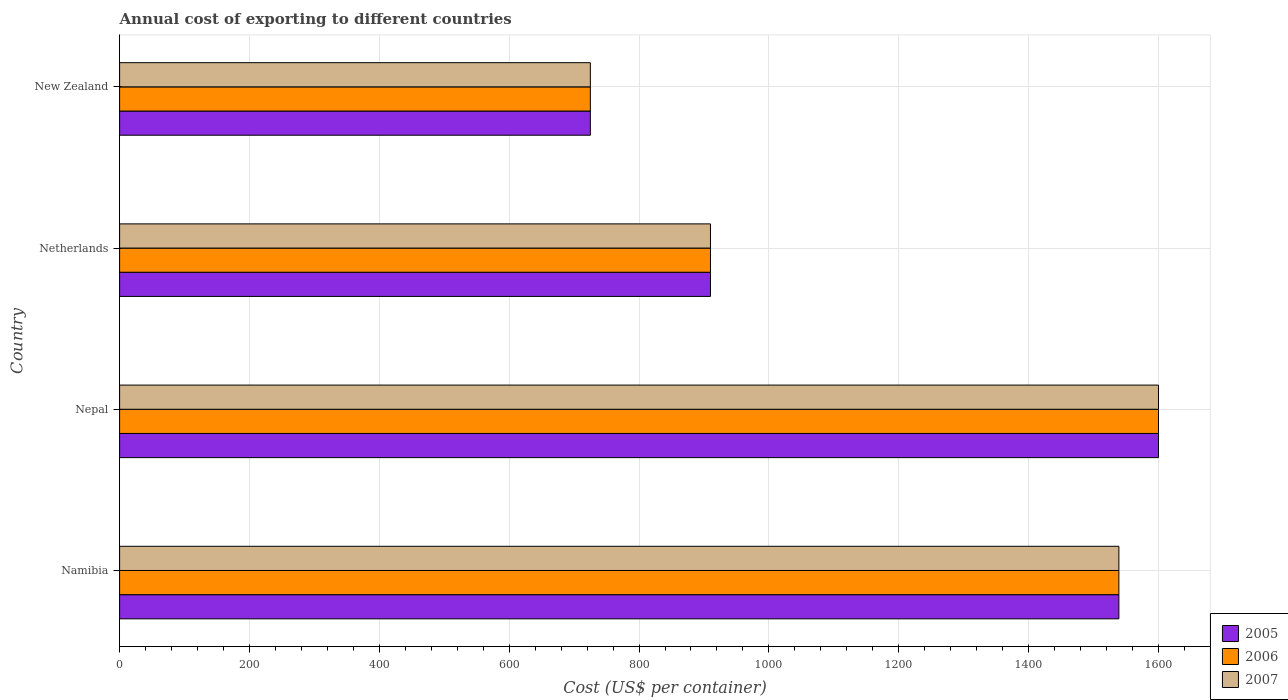How many different coloured bars are there?
Offer a terse response. 3. How many groups of bars are there?
Offer a terse response. 4. Are the number of bars per tick equal to the number of legend labels?
Your answer should be very brief. Yes. Are the number of bars on each tick of the Y-axis equal?
Your response must be concise. Yes. What is the label of the 3rd group of bars from the top?
Provide a short and direct response. Nepal. In how many cases, is the number of bars for a given country not equal to the number of legend labels?
Provide a succinct answer. 0. What is the total annual cost of exporting in 2005 in New Zealand?
Provide a succinct answer. 725. Across all countries, what is the maximum total annual cost of exporting in 2007?
Your response must be concise. 1600. Across all countries, what is the minimum total annual cost of exporting in 2007?
Your answer should be very brief. 725. In which country was the total annual cost of exporting in 2007 maximum?
Your answer should be very brief. Nepal. In which country was the total annual cost of exporting in 2005 minimum?
Offer a very short reply. New Zealand. What is the total total annual cost of exporting in 2007 in the graph?
Ensure brevity in your answer.  4774. What is the difference between the total annual cost of exporting in 2006 in Namibia and that in Netherlands?
Your answer should be compact. 629. What is the difference between the total annual cost of exporting in 2005 in New Zealand and the total annual cost of exporting in 2007 in Netherlands?
Offer a terse response. -185. What is the average total annual cost of exporting in 2005 per country?
Provide a succinct answer. 1193.5. What is the difference between the total annual cost of exporting in 2006 and total annual cost of exporting in 2007 in New Zealand?
Offer a terse response. 0. In how many countries, is the total annual cost of exporting in 2005 greater than 920 US$?
Offer a terse response. 2. What is the ratio of the total annual cost of exporting in 2007 in Namibia to that in Nepal?
Ensure brevity in your answer.  0.96. Is the difference between the total annual cost of exporting in 2006 in Namibia and Nepal greater than the difference between the total annual cost of exporting in 2007 in Namibia and Nepal?
Ensure brevity in your answer.  No. What is the difference between the highest and the lowest total annual cost of exporting in 2006?
Your response must be concise. 875. In how many countries, is the total annual cost of exporting in 2006 greater than the average total annual cost of exporting in 2006 taken over all countries?
Make the answer very short. 2. Is the sum of the total annual cost of exporting in 2006 in Nepal and Netherlands greater than the maximum total annual cost of exporting in 2007 across all countries?
Give a very brief answer. Yes. Is it the case that in every country, the sum of the total annual cost of exporting in 2005 and total annual cost of exporting in 2006 is greater than the total annual cost of exporting in 2007?
Make the answer very short. Yes. What is the difference between two consecutive major ticks on the X-axis?
Make the answer very short. 200. Are the values on the major ticks of X-axis written in scientific E-notation?
Make the answer very short. No. Does the graph contain any zero values?
Your answer should be compact. No. Does the graph contain grids?
Keep it short and to the point. Yes. Where does the legend appear in the graph?
Make the answer very short. Bottom right. How many legend labels are there?
Offer a terse response. 3. What is the title of the graph?
Your response must be concise. Annual cost of exporting to different countries. What is the label or title of the X-axis?
Keep it short and to the point. Cost (US$ per container). What is the Cost (US$ per container) in 2005 in Namibia?
Provide a short and direct response. 1539. What is the Cost (US$ per container) in 2006 in Namibia?
Your answer should be compact. 1539. What is the Cost (US$ per container) of 2007 in Namibia?
Give a very brief answer. 1539. What is the Cost (US$ per container) of 2005 in Nepal?
Keep it short and to the point. 1600. What is the Cost (US$ per container) of 2006 in Nepal?
Your answer should be very brief. 1600. What is the Cost (US$ per container) in 2007 in Nepal?
Your answer should be compact. 1600. What is the Cost (US$ per container) in 2005 in Netherlands?
Offer a very short reply. 910. What is the Cost (US$ per container) of 2006 in Netherlands?
Ensure brevity in your answer.  910. What is the Cost (US$ per container) of 2007 in Netherlands?
Your answer should be compact. 910. What is the Cost (US$ per container) of 2005 in New Zealand?
Ensure brevity in your answer.  725. What is the Cost (US$ per container) of 2006 in New Zealand?
Your answer should be very brief. 725. What is the Cost (US$ per container) in 2007 in New Zealand?
Provide a short and direct response. 725. Across all countries, what is the maximum Cost (US$ per container) in 2005?
Ensure brevity in your answer.  1600. Across all countries, what is the maximum Cost (US$ per container) of 2006?
Offer a very short reply. 1600. Across all countries, what is the maximum Cost (US$ per container) in 2007?
Your answer should be very brief. 1600. Across all countries, what is the minimum Cost (US$ per container) in 2005?
Ensure brevity in your answer.  725. Across all countries, what is the minimum Cost (US$ per container) in 2006?
Give a very brief answer. 725. Across all countries, what is the minimum Cost (US$ per container) in 2007?
Your response must be concise. 725. What is the total Cost (US$ per container) in 2005 in the graph?
Your answer should be compact. 4774. What is the total Cost (US$ per container) of 2006 in the graph?
Your response must be concise. 4774. What is the total Cost (US$ per container) of 2007 in the graph?
Make the answer very short. 4774. What is the difference between the Cost (US$ per container) of 2005 in Namibia and that in Nepal?
Provide a succinct answer. -61. What is the difference between the Cost (US$ per container) in 2006 in Namibia and that in Nepal?
Your response must be concise. -61. What is the difference between the Cost (US$ per container) of 2007 in Namibia and that in Nepal?
Give a very brief answer. -61. What is the difference between the Cost (US$ per container) of 2005 in Namibia and that in Netherlands?
Keep it short and to the point. 629. What is the difference between the Cost (US$ per container) of 2006 in Namibia and that in Netherlands?
Provide a short and direct response. 629. What is the difference between the Cost (US$ per container) of 2007 in Namibia and that in Netherlands?
Your response must be concise. 629. What is the difference between the Cost (US$ per container) of 2005 in Namibia and that in New Zealand?
Offer a very short reply. 814. What is the difference between the Cost (US$ per container) in 2006 in Namibia and that in New Zealand?
Your answer should be very brief. 814. What is the difference between the Cost (US$ per container) of 2007 in Namibia and that in New Zealand?
Ensure brevity in your answer.  814. What is the difference between the Cost (US$ per container) in 2005 in Nepal and that in Netherlands?
Provide a short and direct response. 690. What is the difference between the Cost (US$ per container) in 2006 in Nepal and that in Netherlands?
Ensure brevity in your answer.  690. What is the difference between the Cost (US$ per container) in 2007 in Nepal and that in Netherlands?
Ensure brevity in your answer.  690. What is the difference between the Cost (US$ per container) of 2005 in Nepal and that in New Zealand?
Provide a succinct answer. 875. What is the difference between the Cost (US$ per container) of 2006 in Nepal and that in New Zealand?
Your answer should be very brief. 875. What is the difference between the Cost (US$ per container) in 2007 in Nepal and that in New Zealand?
Your answer should be very brief. 875. What is the difference between the Cost (US$ per container) in 2005 in Netherlands and that in New Zealand?
Your response must be concise. 185. What is the difference between the Cost (US$ per container) in 2006 in Netherlands and that in New Zealand?
Your answer should be very brief. 185. What is the difference between the Cost (US$ per container) in 2007 in Netherlands and that in New Zealand?
Provide a succinct answer. 185. What is the difference between the Cost (US$ per container) of 2005 in Namibia and the Cost (US$ per container) of 2006 in Nepal?
Your answer should be very brief. -61. What is the difference between the Cost (US$ per container) of 2005 in Namibia and the Cost (US$ per container) of 2007 in Nepal?
Give a very brief answer. -61. What is the difference between the Cost (US$ per container) of 2006 in Namibia and the Cost (US$ per container) of 2007 in Nepal?
Provide a succinct answer. -61. What is the difference between the Cost (US$ per container) in 2005 in Namibia and the Cost (US$ per container) in 2006 in Netherlands?
Your answer should be very brief. 629. What is the difference between the Cost (US$ per container) in 2005 in Namibia and the Cost (US$ per container) in 2007 in Netherlands?
Make the answer very short. 629. What is the difference between the Cost (US$ per container) of 2006 in Namibia and the Cost (US$ per container) of 2007 in Netherlands?
Offer a terse response. 629. What is the difference between the Cost (US$ per container) of 2005 in Namibia and the Cost (US$ per container) of 2006 in New Zealand?
Your answer should be very brief. 814. What is the difference between the Cost (US$ per container) in 2005 in Namibia and the Cost (US$ per container) in 2007 in New Zealand?
Offer a very short reply. 814. What is the difference between the Cost (US$ per container) of 2006 in Namibia and the Cost (US$ per container) of 2007 in New Zealand?
Your response must be concise. 814. What is the difference between the Cost (US$ per container) of 2005 in Nepal and the Cost (US$ per container) of 2006 in Netherlands?
Offer a very short reply. 690. What is the difference between the Cost (US$ per container) of 2005 in Nepal and the Cost (US$ per container) of 2007 in Netherlands?
Offer a terse response. 690. What is the difference between the Cost (US$ per container) in 2006 in Nepal and the Cost (US$ per container) in 2007 in Netherlands?
Your response must be concise. 690. What is the difference between the Cost (US$ per container) of 2005 in Nepal and the Cost (US$ per container) of 2006 in New Zealand?
Your answer should be compact. 875. What is the difference between the Cost (US$ per container) of 2005 in Nepal and the Cost (US$ per container) of 2007 in New Zealand?
Keep it short and to the point. 875. What is the difference between the Cost (US$ per container) of 2006 in Nepal and the Cost (US$ per container) of 2007 in New Zealand?
Your answer should be very brief. 875. What is the difference between the Cost (US$ per container) of 2005 in Netherlands and the Cost (US$ per container) of 2006 in New Zealand?
Offer a terse response. 185. What is the difference between the Cost (US$ per container) of 2005 in Netherlands and the Cost (US$ per container) of 2007 in New Zealand?
Provide a succinct answer. 185. What is the difference between the Cost (US$ per container) of 2006 in Netherlands and the Cost (US$ per container) of 2007 in New Zealand?
Offer a terse response. 185. What is the average Cost (US$ per container) in 2005 per country?
Offer a terse response. 1193.5. What is the average Cost (US$ per container) of 2006 per country?
Provide a succinct answer. 1193.5. What is the average Cost (US$ per container) of 2007 per country?
Keep it short and to the point. 1193.5. What is the difference between the Cost (US$ per container) of 2005 and Cost (US$ per container) of 2007 in Namibia?
Offer a terse response. 0. What is the difference between the Cost (US$ per container) in 2005 and Cost (US$ per container) in 2007 in Nepal?
Offer a very short reply. 0. What is the difference between the Cost (US$ per container) in 2006 and Cost (US$ per container) in 2007 in Nepal?
Keep it short and to the point. 0. What is the difference between the Cost (US$ per container) of 2006 and Cost (US$ per container) of 2007 in New Zealand?
Provide a succinct answer. 0. What is the ratio of the Cost (US$ per container) in 2005 in Namibia to that in Nepal?
Provide a short and direct response. 0.96. What is the ratio of the Cost (US$ per container) in 2006 in Namibia to that in Nepal?
Provide a succinct answer. 0.96. What is the ratio of the Cost (US$ per container) in 2007 in Namibia to that in Nepal?
Your answer should be very brief. 0.96. What is the ratio of the Cost (US$ per container) in 2005 in Namibia to that in Netherlands?
Provide a succinct answer. 1.69. What is the ratio of the Cost (US$ per container) of 2006 in Namibia to that in Netherlands?
Ensure brevity in your answer.  1.69. What is the ratio of the Cost (US$ per container) in 2007 in Namibia to that in Netherlands?
Provide a short and direct response. 1.69. What is the ratio of the Cost (US$ per container) of 2005 in Namibia to that in New Zealand?
Offer a very short reply. 2.12. What is the ratio of the Cost (US$ per container) of 2006 in Namibia to that in New Zealand?
Keep it short and to the point. 2.12. What is the ratio of the Cost (US$ per container) of 2007 in Namibia to that in New Zealand?
Your answer should be compact. 2.12. What is the ratio of the Cost (US$ per container) in 2005 in Nepal to that in Netherlands?
Offer a very short reply. 1.76. What is the ratio of the Cost (US$ per container) in 2006 in Nepal to that in Netherlands?
Give a very brief answer. 1.76. What is the ratio of the Cost (US$ per container) in 2007 in Nepal to that in Netherlands?
Ensure brevity in your answer.  1.76. What is the ratio of the Cost (US$ per container) in 2005 in Nepal to that in New Zealand?
Your answer should be compact. 2.21. What is the ratio of the Cost (US$ per container) in 2006 in Nepal to that in New Zealand?
Ensure brevity in your answer.  2.21. What is the ratio of the Cost (US$ per container) of 2007 in Nepal to that in New Zealand?
Ensure brevity in your answer.  2.21. What is the ratio of the Cost (US$ per container) of 2005 in Netherlands to that in New Zealand?
Provide a succinct answer. 1.26. What is the ratio of the Cost (US$ per container) in 2006 in Netherlands to that in New Zealand?
Keep it short and to the point. 1.26. What is the ratio of the Cost (US$ per container) of 2007 in Netherlands to that in New Zealand?
Your answer should be very brief. 1.26. What is the difference between the highest and the second highest Cost (US$ per container) of 2005?
Your answer should be compact. 61. What is the difference between the highest and the second highest Cost (US$ per container) in 2006?
Your answer should be very brief. 61. What is the difference between the highest and the lowest Cost (US$ per container) of 2005?
Make the answer very short. 875. What is the difference between the highest and the lowest Cost (US$ per container) in 2006?
Ensure brevity in your answer.  875. What is the difference between the highest and the lowest Cost (US$ per container) of 2007?
Your answer should be compact. 875. 